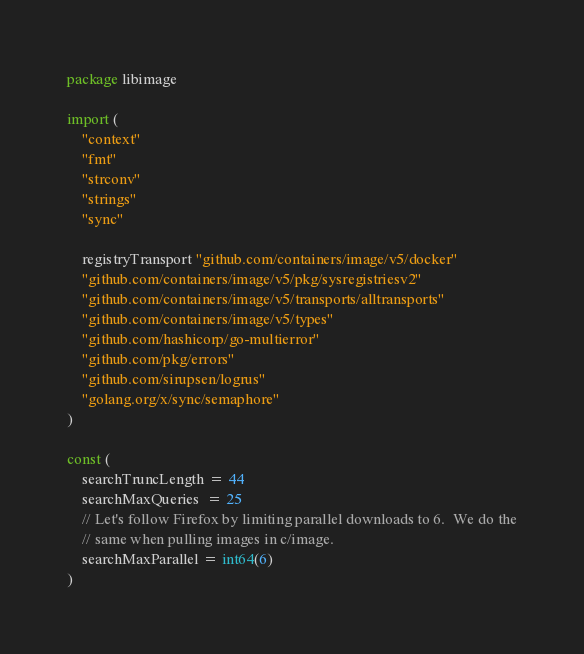Convert code to text. <code><loc_0><loc_0><loc_500><loc_500><_Go_>package libimage

import (
	"context"
	"fmt"
	"strconv"
	"strings"
	"sync"

	registryTransport "github.com/containers/image/v5/docker"
	"github.com/containers/image/v5/pkg/sysregistriesv2"
	"github.com/containers/image/v5/transports/alltransports"
	"github.com/containers/image/v5/types"
	"github.com/hashicorp/go-multierror"
	"github.com/pkg/errors"
	"github.com/sirupsen/logrus"
	"golang.org/x/sync/semaphore"
)

const (
	searchTruncLength = 44
	searchMaxQueries  = 25
	// Let's follow Firefox by limiting parallel downloads to 6.  We do the
	// same when pulling images in c/image.
	searchMaxParallel = int64(6)
)
</code> 